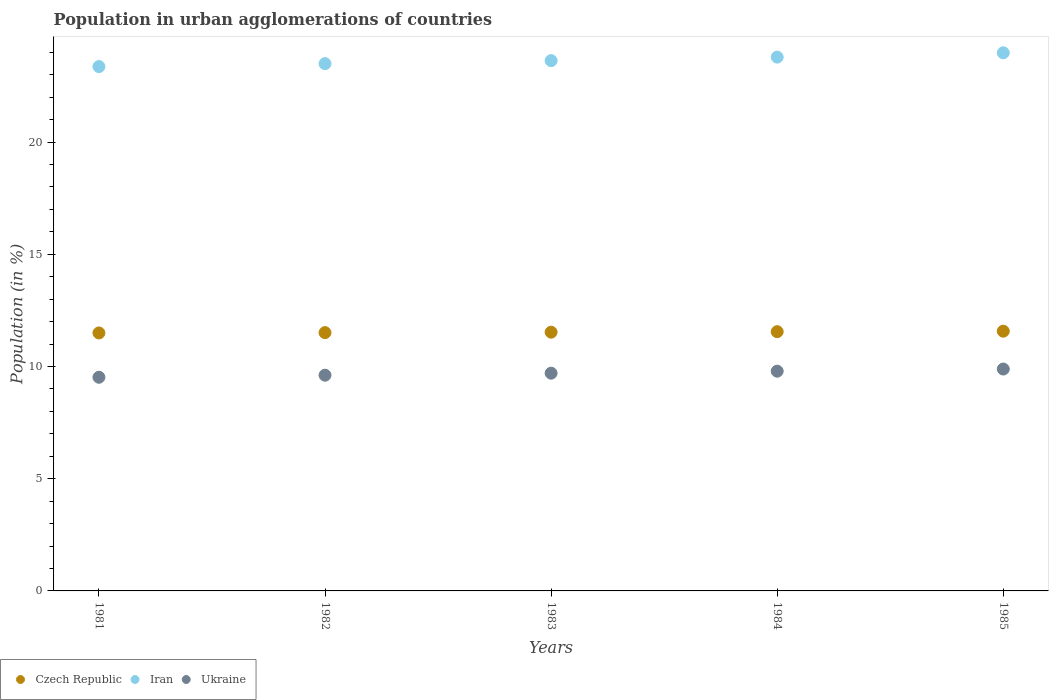How many different coloured dotlines are there?
Make the answer very short. 3. Is the number of dotlines equal to the number of legend labels?
Provide a succinct answer. Yes. What is the percentage of population in urban agglomerations in Czech Republic in 1985?
Provide a succinct answer. 11.57. Across all years, what is the maximum percentage of population in urban agglomerations in Czech Republic?
Keep it short and to the point. 11.57. Across all years, what is the minimum percentage of population in urban agglomerations in Czech Republic?
Your response must be concise. 11.5. What is the total percentage of population in urban agglomerations in Ukraine in the graph?
Offer a very short reply. 48.52. What is the difference between the percentage of population in urban agglomerations in Czech Republic in 1981 and that in 1983?
Ensure brevity in your answer.  -0.03. What is the difference between the percentage of population in urban agglomerations in Ukraine in 1984 and the percentage of population in urban agglomerations in Iran in 1982?
Your response must be concise. -13.7. What is the average percentage of population in urban agglomerations in Iran per year?
Offer a very short reply. 23.65. In the year 1984, what is the difference between the percentage of population in urban agglomerations in Czech Republic and percentage of population in urban agglomerations in Ukraine?
Your response must be concise. 1.76. What is the ratio of the percentage of population in urban agglomerations in Iran in 1982 to that in 1983?
Your answer should be compact. 0.99. Is the difference between the percentage of population in urban agglomerations in Czech Republic in 1982 and 1984 greater than the difference between the percentage of population in urban agglomerations in Ukraine in 1982 and 1984?
Offer a terse response. Yes. What is the difference between the highest and the second highest percentage of population in urban agglomerations in Iran?
Offer a terse response. 0.19. What is the difference between the highest and the lowest percentage of population in urban agglomerations in Czech Republic?
Your answer should be compact. 0.08. Is the percentage of population in urban agglomerations in Czech Republic strictly less than the percentage of population in urban agglomerations in Iran over the years?
Offer a terse response. Yes. Are the values on the major ticks of Y-axis written in scientific E-notation?
Provide a succinct answer. No. Where does the legend appear in the graph?
Provide a succinct answer. Bottom left. How many legend labels are there?
Your answer should be compact. 3. How are the legend labels stacked?
Make the answer very short. Horizontal. What is the title of the graph?
Keep it short and to the point. Population in urban agglomerations of countries. What is the label or title of the Y-axis?
Your answer should be very brief. Population (in %). What is the Population (in %) in Czech Republic in 1981?
Make the answer very short. 11.5. What is the Population (in %) of Iran in 1981?
Ensure brevity in your answer.  23.37. What is the Population (in %) of Ukraine in 1981?
Your answer should be very brief. 9.52. What is the Population (in %) in Czech Republic in 1982?
Provide a succinct answer. 11.51. What is the Population (in %) of Iran in 1982?
Offer a terse response. 23.5. What is the Population (in %) of Ukraine in 1982?
Offer a very short reply. 9.61. What is the Population (in %) of Czech Republic in 1983?
Keep it short and to the point. 11.53. What is the Population (in %) of Iran in 1983?
Your answer should be very brief. 23.63. What is the Population (in %) in Ukraine in 1983?
Your answer should be very brief. 9.7. What is the Population (in %) of Czech Republic in 1984?
Your response must be concise. 11.55. What is the Population (in %) in Iran in 1984?
Your response must be concise. 23.79. What is the Population (in %) in Ukraine in 1984?
Provide a short and direct response. 9.79. What is the Population (in %) of Czech Republic in 1985?
Provide a succinct answer. 11.57. What is the Population (in %) of Iran in 1985?
Offer a terse response. 23.98. What is the Population (in %) of Ukraine in 1985?
Provide a short and direct response. 9.89. Across all years, what is the maximum Population (in %) of Czech Republic?
Offer a very short reply. 11.57. Across all years, what is the maximum Population (in %) in Iran?
Your answer should be compact. 23.98. Across all years, what is the maximum Population (in %) of Ukraine?
Offer a terse response. 9.89. Across all years, what is the minimum Population (in %) of Czech Republic?
Give a very brief answer. 11.5. Across all years, what is the minimum Population (in %) of Iran?
Offer a terse response. 23.37. Across all years, what is the minimum Population (in %) of Ukraine?
Offer a terse response. 9.52. What is the total Population (in %) of Czech Republic in the graph?
Your response must be concise. 57.66. What is the total Population (in %) in Iran in the graph?
Provide a short and direct response. 118.26. What is the total Population (in %) in Ukraine in the graph?
Keep it short and to the point. 48.52. What is the difference between the Population (in %) in Czech Republic in 1981 and that in 1982?
Your answer should be compact. -0.01. What is the difference between the Population (in %) of Iran in 1981 and that in 1982?
Ensure brevity in your answer.  -0.13. What is the difference between the Population (in %) in Ukraine in 1981 and that in 1982?
Offer a terse response. -0.09. What is the difference between the Population (in %) of Czech Republic in 1981 and that in 1983?
Your answer should be compact. -0.03. What is the difference between the Population (in %) of Iran in 1981 and that in 1983?
Keep it short and to the point. -0.27. What is the difference between the Population (in %) in Ukraine in 1981 and that in 1983?
Provide a succinct answer. -0.18. What is the difference between the Population (in %) of Czech Republic in 1981 and that in 1984?
Give a very brief answer. -0.06. What is the difference between the Population (in %) in Iran in 1981 and that in 1984?
Your answer should be compact. -0.42. What is the difference between the Population (in %) of Ukraine in 1981 and that in 1984?
Offer a very short reply. -0.27. What is the difference between the Population (in %) in Czech Republic in 1981 and that in 1985?
Make the answer very short. -0.08. What is the difference between the Population (in %) in Iran in 1981 and that in 1985?
Offer a terse response. -0.61. What is the difference between the Population (in %) of Ukraine in 1981 and that in 1985?
Make the answer very short. -0.37. What is the difference between the Population (in %) in Czech Republic in 1982 and that in 1983?
Keep it short and to the point. -0.02. What is the difference between the Population (in %) of Iran in 1982 and that in 1983?
Offer a terse response. -0.13. What is the difference between the Population (in %) of Ukraine in 1982 and that in 1983?
Offer a very short reply. -0.09. What is the difference between the Population (in %) of Czech Republic in 1982 and that in 1984?
Offer a very short reply. -0.04. What is the difference between the Population (in %) in Iran in 1982 and that in 1984?
Make the answer very short. -0.29. What is the difference between the Population (in %) of Ukraine in 1982 and that in 1984?
Your answer should be compact. -0.18. What is the difference between the Population (in %) of Czech Republic in 1982 and that in 1985?
Provide a short and direct response. -0.06. What is the difference between the Population (in %) of Iran in 1982 and that in 1985?
Your response must be concise. -0.48. What is the difference between the Population (in %) of Ukraine in 1982 and that in 1985?
Your answer should be compact. -0.27. What is the difference between the Population (in %) in Czech Republic in 1983 and that in 1984?
Make the answer very short. -0.02. What is the difference between the Population (in %) of Iran in 1983 and that in 1984?
Keep it short and to the point. -0.16. What is the difference between the Population (in %) of Ukraine in 1983 and that in 1984?
Give a very brief answer. -0.09. What is the difference between the Population (in %) of Czech Republic in 1983 and that in 1985?
Give a very brief answer. -0.04. What is the difference between the Population (in %) of Iran in 1983 and that in 1985?
Ensure brevity in your answer.  -0.35. What is the difference between the Population (in %) in Ukraine in 1983 and that in 1985?
Your response must be concise. -0.18. What is the difference between the Population (in %) of Czech Republic in 1984 and that in 1985?
Give a very brief answer. -0.02. What is the difference between the Population (in %) of Iran in 1984 and that in 1985?
Offer a terse response. -0.19. What is the difference between the Population (in %) of Ukraine in 1984 and that in 1985?
Provide a succinct answer. -0.1. What is the difference between the Population (in %) of Czech Republic in 1981 and the Population (in %) of Iran in 1982?
Your answer should be very brief. -12. What is the difference between the Population (in %) of Czech Republic in 1981 and the Population (in %) of Ukraine in 1982?
Your answer should be compact. 1.88. What is the difference between the Population (in %) in Iran in 1981 and the Population (in %) in Ukraine in 1982?
Provide a short and direct response. 13.75. What is the difference between the Population (in %) of Czech Republic in 1981 and the Population (in %) of Iran in 1983?
Offer a very short reply. -12.13. What is the difference between the Population (in %) of Czech Republic in 1981 and the Population (in %) of Ukraine in 1983?
Your answer should be very brief. 1.79. What is the difference between the Population (in %) of Iran in 1981 and the Population (in %) of Ukraine in 1983?
Make the answer very short. 13.66. What is the difference between the Population (in %) of Czech Republic in 1981 and the Population (in %) of Iran in 1984?
Provide a succinct answer. -12.29. What is the difference between the Population (in %) of Czech Republic in 1981 and the Population (in %) of Ukraine in 1984?
Your response must be concise. 1.7. What is the difference between the Population (in %) in Iran in 1981 and the Population (in %) in Ukraine in 1984?
Make the answer very short. 13.57. What is the difference between the Population (in %) of Czech Republic in 1981 and the Population (in %) of Iran in 1985?
Offer a very short reply. -12.48. What is the difference between the Population (in %) of Czech Republic in 1981 and the Population (in %) of Ukraine in 1985?
Ensure brevity in your answer.  1.61. What is the difference between the Population (in %) in Iran in 1981 and the Population (in %) in Ukraine in 1985?
Give a very brief answer. 13.48. What is the difference between the Population (in %) of Czech Republic in 1982 and the Population (in %) of Iran in 1983?
Keep it short and to the point. -12.12. What is the difference between the Population (in %) of Czech Republic in 1982 and the Population (in %) of Ukraine in 1983?
Your answer should be very brief. 1.81. What is the difference between the Population (in %) in Iran in 1982 and the Population (in %) in Ukraine in 1983?
Your answer should be very brief. 13.79. What is the difference between the Population (in %) in Czech Republic in 1982 and the Population (in %) in Iran in 1984?
Your answer should be very brief. -12.28. What is the difference between the Population (in %) of Czech Republic in 1982 and the Population (in %) of Ukraine in 1984?
Give a very brief answer. 1.72. What is the difference between the Population (in %) in Iran in 1982 and the Population (in %) in Ukraine in 1984?
Keep it short and to the point. 13.7. What is the difference between the Population (in %) of Czech Republic in 1982 and the Population (in %) of Iran in 1985?
Your answer should be compact. -12.47. What is the difference between the Population (in %) in Czech Republic in 1982 and the Population (in %) in Ukraine in 1985?
Give a very brief answer. 1.62. What is the difference between the Population (in %) of Iran in 1982 and the Population (in %) of Ukraine in 1985?
Give a very brief answer. 13.61. What is the difference between the Population (in %) of Czech Republic in 1983 and the Population (in %) of Iran in 1984?
Keep it short and to the point. -12.26. What is the difference between the Population (in %) of Czech Republic in 1983 and the Population (in %) of Ukraine in 1984?
Keep it short and to the point. 1.74. What is the difference between the Population (in %) of Iran in 1983 and the Population (in %) of Ukraine in 1984?
Your answer should be very brief. 13.84. What is the difference between the Population (in %) of Czech Republic in 1983 and the Population (in %) of Iran in 1985?
Make the answer very short. -12.45. What is the difference between the Population (in %) of Czech Republic in 1983 and the Population (in %) of Ukraine in 1985?
Give a very brief answer. 1.64. What is the difference between the Population (in %) in Iran in 1983 and the Population (in %) in Ukraine in 1985?
Provide a succinct answer. 13.74. What is the difference between the Population (in %) of Czech Republic in 1984 and the Population (in %) of Iran in 1985?
Give a very brief answer. -12.43. What is the difference between the Population (in %) in Czech Republic in 1984 and the Population (in %) in Ukraine in 1985?
Keep it short and to the point. 1.67. What is the difference between the Population (in %) of Iran in 1984 and the Population (in %) of Ukraine in 1985?
Offer a very short reply. 13.9. What is the average Population (in %) in Czech Republic per year?
Provide a succinct answer. 11.53. What is the average Population (in %) in Iran per year?
Your answer should be very brief. 23.65. What is the average Population (in %) in Ukraine per year?
Ensure brevity in your answer.  9.7. In the year 1981, what is the difference between the Population (in %) in Czech Republic and Population (in %) in Iran?
Provide a succinct answer. -11.87. In the year 1981, what is the difference between the Population (in %) in Czech Republic and Population (in %) in Ukraine?
Provide a succinct answer. 1.97. In the year 1981, what is the difference between the Population (in %) of Iran and Population (in %) of Ukraine?
Ensure brevity in your answer.  13.84. In the year 1982, what is the difference between the Population (in %) in Czech Republic and Population (in %) in Iran?
Your answer should be compact. -11.99. In the year 1982, what is the difference between the Population (in %) in Czech Republic and Population (in %) in Ukraine?
Your response must be concise. 1.9. In the year 1982, what is the difference between the Population (in %) in Iran and Population (in %) in Ukraine?
Make the answer very short. 13.88. In the year 1983, what is the difference between the Population (in %) of Czech Republic and Population (in %) of Iran?
Make the answer very short. -12.1. In the year 1983, what is the difference between the Population (in %) of Czech Republic and Population (in %) of Ukraine?
Give a very brief answer. 1.83. In the year 1983, what is the difference between the Population (in %) of Iran and Population (in %) of Ukraine?
Your answer should be compact. 13.93. In the year 1984, what is the difference between the Population (in %) of Czech Republic and Population (in %) of Iran?
Make the answer very short. -12.24. In the year 1984, what is the difference between the Population (in %) of Czech Republic and Population (in %) of Ukraine?
Make the answer very short. 1.76. In the year 1984, what is the difference between the Population (in %) in Iran and Population (in %) in Ukraine?
Your response must be concise. 14. In the year 1985, what is the difference between the Population (in %) of Czech Republic and Population (in %) of Iran?
Your answer should be compact. -12.41. In the year 1985, what is the difference between the Population (in %) of Czech Republic and Population (in %) of Ukraine?
Ensure brevity in your answer.  1.69. In the year 1985, what is the difference between the Population (in %) in Iran and Population (in %) in Ukraine?
Offer a very short reply. 14.09. What is the ratio of the Population (in %) of Iran in 1981 to that in 1982?
Keep it short and to the point. 0.99. What is the ratio of the Population (in %) in Ukraine in 1981 to that in 1982?
Give a very brief answer. 0.99. What is the ratio of the Population (in %) in Iran in 1981 to that in 1983?
Offer a terse response. 0.99. What is the ratio of the Population (in %) in Ukraine in 1981 to that in 1983?
Your answer should be compact. 0.98. What is the ratio of the Population (in %) in Czech Republic in 1981 to that in 1984?
Ensure brevity in your answer.  1. What is the ratio of the Population (in %) in Iran in 1981 to that in 1984?
Your answer should be compact. 0.98. What is the ratio of the Population (in %) of Ukraine in 1981 to that in 1984?
Ensure brevity in your answer.  0.97. What is the ratio of the Population (in %) in Czech Republic in 1981 to that in 1985?
Offer a very short reply. 0.99. What is the ratio of the Population (in %) of Iran in 1981 to that in 1985?
Your response must be concise. 0.97. What is the ratio of the Population (in %) of Czech Republic in 1982 to that in 1983?
Provide a short and direct response. 1. What is the ratio of the Population (in %) of Iran in 1982 to that in 1983?
Your answer should be compact. 0.99. What is the ratio of the Population (in %) of Ukraine in 1982 to that in 1984?
Offer a very short reply. 0.98. What is the ratio of the Population (in %) in Iran in 1982 to that in 1985?
Provide a short and direct response. 0.98. What is the ratio of the Population (in %) in Ukraine in 1982 to that in 1985?
Your response must be concise. 0.97. What is the ratio of the Population (in %) of Iran in 1983 to that in 1984?
Your response must be concise. 0.99. What is the ratio of the Population (in %) of Ukraine in 1983 to that in 1984?
Keep it short and to the point. 0.99. What is the ratio of the Population (in %) of Czech Republic in 1983 to that in 1985?
Your answer should be compact. 1. What is the ratio of the Population (in %) in Iran in 1983 to that in 1985?
Your answer should be compact. 0.99. What is the ratio of the Population (in %) of Ukraine in 1983 to that in 1985?
Provide a succinct answer. 0.98. What is the ratio of the Population (in %) in Iran in 1984 to that in 1985?
Your answer should be very brief. 0.99. What is the ratio of the Population (in %) of Ukraine in 1984 to that in 1985?
Your answer should be compact. 0.99. What is the difference between the highest and the second highest Population (in %) in Czech Republic?
Your answer should be very brief. 0.02. What is the difference between the highest and the second highest Population (in %) of Iran?
Ensure brevity in your answer.  0.19. What is the difference between the highest and the second highest Population (in %) of Ukraine?
Your answer should be very brief. 0.1. What is the difference between the highest and the lowest Population (in %) of Czech Republic?
Offer a terse response. 0.08. What is the difference between the highest and the lowest Population (in %) in Iran?
Your response must be concise. 0.61. What is the difference between the highest and the lowest Population (in %) in Ukraine?
Provide a succinct answer. 0.37. 